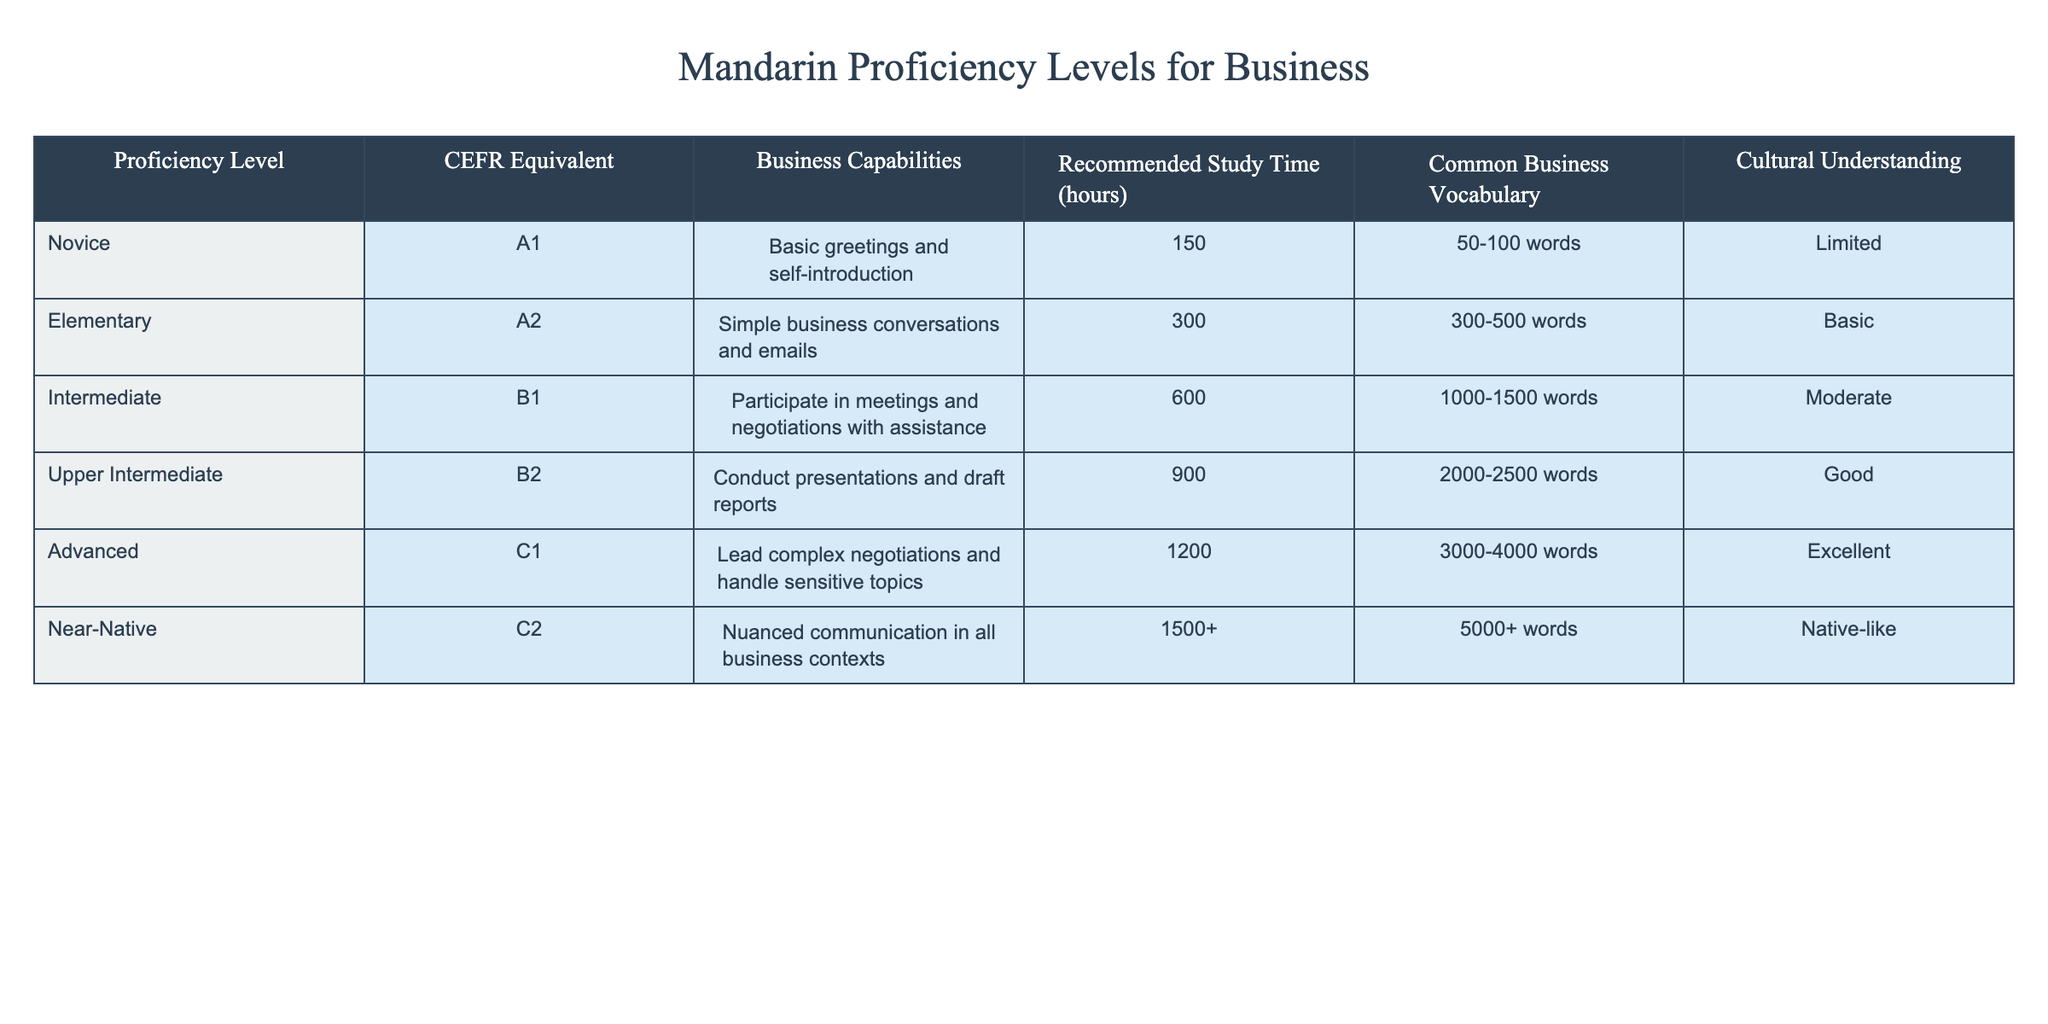What is the recommended study time for an Advanced proficiency level? The table states that the recommended study time for Advanced proficiency (C1) is 1200 hours.
Answer: 1200 hours How many business capabilities are associated with the Upper Intermediate proficiency level? The Upper Intermediate level (B2) has 3 business capabilities listed: conducting presentations, drafting reports, and managing internal communication.
Answer: 3 Is it true that the Novice proficiency level allows for basic greetings and self-introduction? Referring to the table, it shows that the Novice level (A1) does allow for basic greetings and self-introduction, confirming the statement is true.
Answer: True What is the difference in recommended study time between the Intermediate and Near-Native levels? The Intermediate (B1) level requires 600 hours, and the Near-Native (C2) level requires 1500+ hours. The difference is 1500 - 600 = 900 hours.
Answer: 900 hours Which proficiency level has the most extensive common business vocabulary? Looking at the table, Near-Native (C2) proficiency has 5000+ words of common business vocabulary, indicating it has the most.
Answer: Near-Native (C2) If a person can only commit 400 hours to study, which proficiency levels can they realistically achieve? Novice (A1) requires 150 hours, and Elementary (A2) requires 300 hours, both of which fall under the 400-hour limit. Intermediate (B1) requires 600 hours, which exceeds this, so Novice and Elementary are achievable.
Answer: Novice (A1) and Elementary (A2) What proficiency level would you achieve with 900 hours of study time? According to the table, with 900 hours, a person would reach Upper Intermediate (B2) proficiency.
Answer: Upper Intermediate (B2) Does the Advanced level provide a high level of cultural understanding? The table indicates that the Advanced level (C1) has an excellent level of cultural understanding, validating the query as true.
Answer: True How many hours of study are needed to progress from Novice to Advanced levels? The recommended study time for Novice is 150 hours and for Advanced is 1200 hours. The total time required is 1200 - 150 = 1050 hours.
Answer: 1050 hours What is the maximum number of words for common business vocabulary at the Elementary proficiency level? The table shows that the Elementary (A2) level has a common business vocabulary of 300-500 words, indicating the maximum is 500 words.
Answer: 500 words Is the ability to handle sensitive topics exclusive to the Advanced proficiency level? The table specifies that only the Advanced (C1) level is associated with handling sensitive topics, confirming the statement is true.
Answer: True 